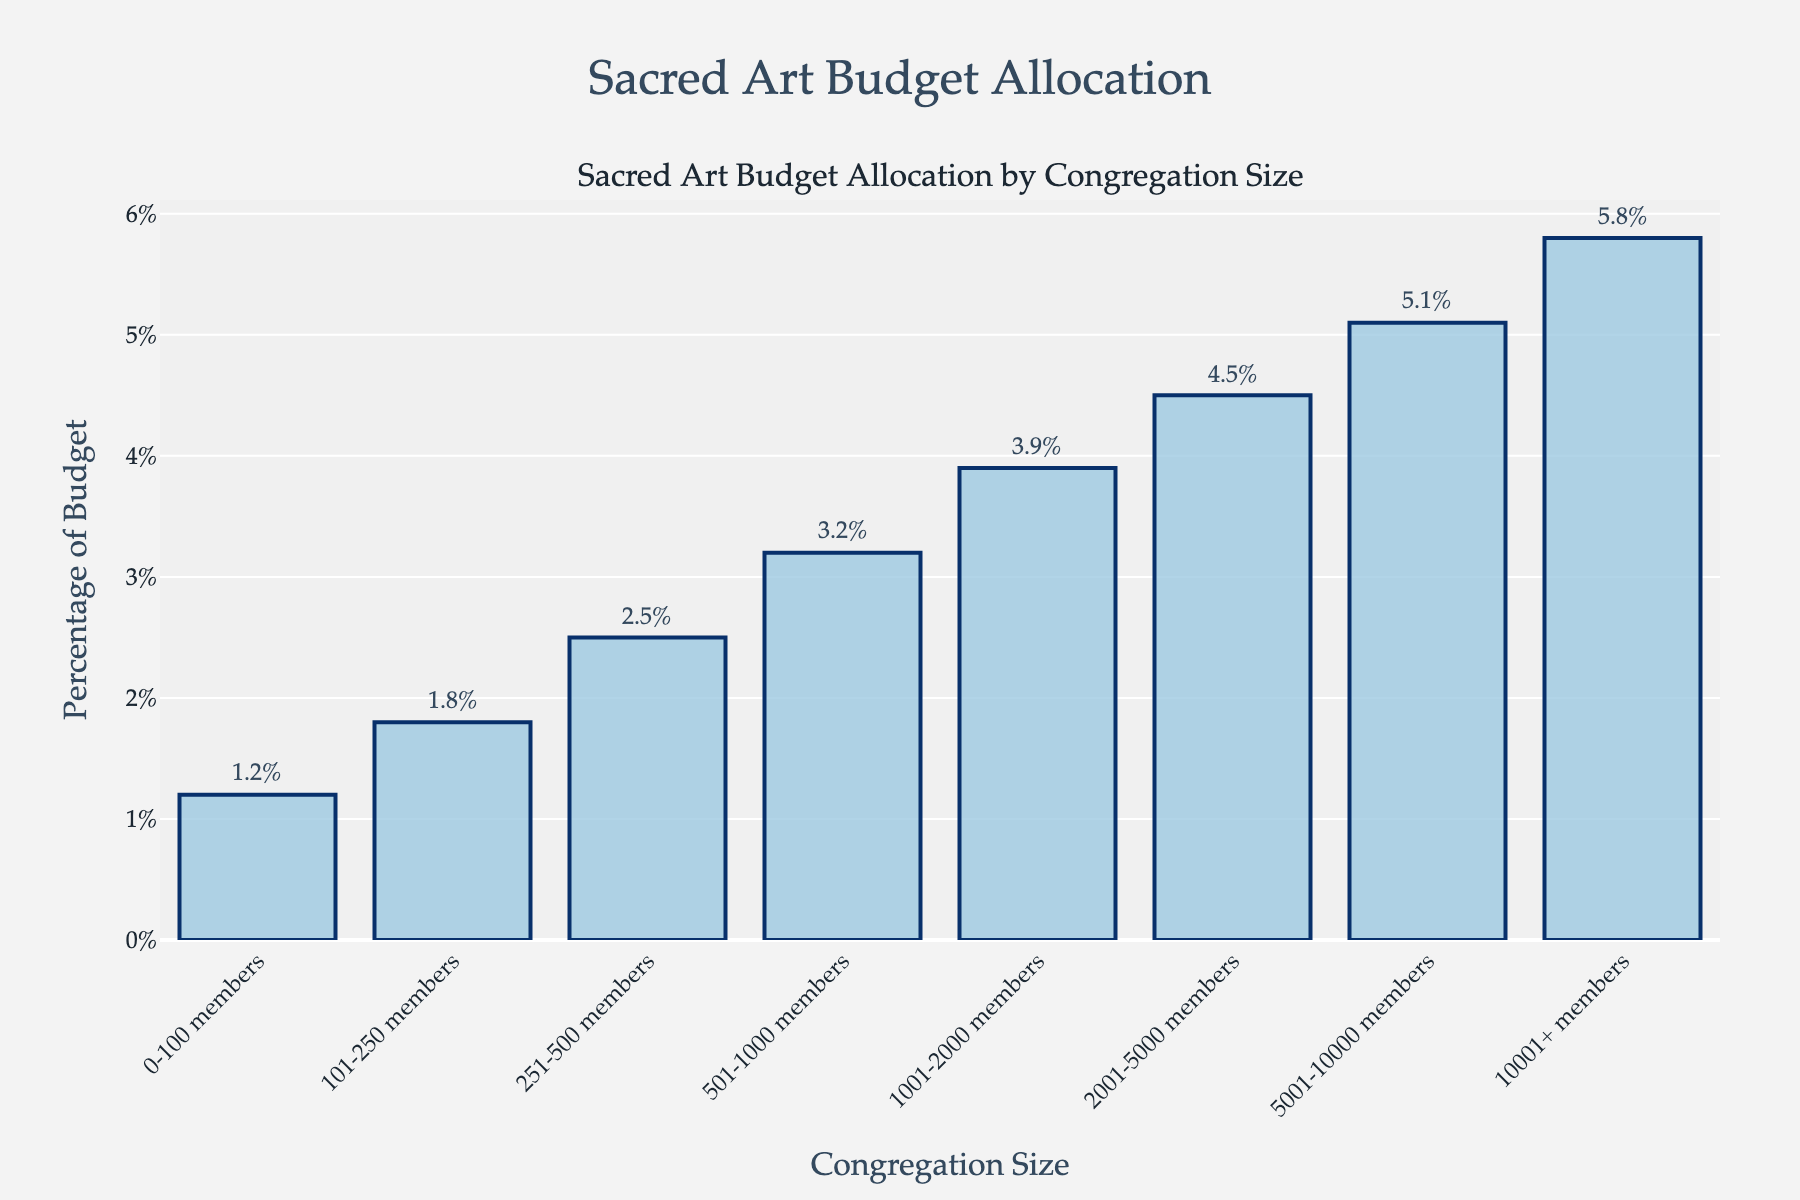How many congregation size categories allocate less than 3% of their budget to sacred art? To answer this, observe the y-axis values for each congregation size category. Count the bars that stay below the 3% mark on the y-axis. There are three such categories.
Answer: 3 By how much does the percentage of the budget for sacred art in congregations with 10001+ members exceed that of congregations with 0-100 members? Look at the percentage values for the congregation sizes 10001+ members and 0-100 members. Subtract the percentage for 0-100 members (1.2%) from the percentage for 10001+ members (5.8%), which results in a difference of 4.6%.
Answer: 4.6% What is the average percentage of the budget for sacred art across all congregation sizes? Add the percentage values for all congregation sizes and divide by the number of categories. Calculations: (1.2 + 1.8 + 2.5 + 3.2 + 3.9 + 4.5 + 5.1 + 5.8) / 8, which equals 3.75%.
Answer: 3.75% Which congregation size has the lowest budget allocation to sacred art, and what percentage is allocated? Compare the height of the bars or the percentage numbers shown for each congregation size. The category with the lowest bar/percentage is 0-100 members, with 1.2%.
Answer: 0-100 members, 1.2% What is the range of budget allocation percentages for sacred art across all congregation sizes? Identify the highest and lowest percentage values from the plot (5.8% for the largest congregation size and 1.2% for the smallest). The range is calculated by subtracting 1.2% from 5.8%, which equals 4.6%.
Answer: 4.6% Which congregation size category has nearly half the budget percentage of the 5001-10000 members category? Find the congregation size with 5001-10000 members, which has a budget percentage of 5.1%. Look for a category whose budget is close to half of 5.1% (approximately 2.55%). The 251-500 members category, with a budget of 2.5%, is closest.
Answer: 251-500 members What trend can be observed in the allocation of budget for sacred art as congregation size increases? Notice the pattern of increasing bar heights and increasing percentage values as the congregation size categories increase. This indicates a positive trend: larger congregation sizes tend to allocate a higher percentage of their budget to sacred art.
Answer: Higher allocation with larger size What is the combined budget percentage for sacred art for congregations with more than 2000 members? Look at the percentages for congregation sizes 2001-5000, 5001-10000, and 10001+ members (4.5%, 5.1%, and 5.8% respectively). Sum these values: 4.5 + 5.1 + 5.8 = 15.4%.
Answer: 15.4% Which congregation size category sees a 0.6% increase in budget allocation for sacred art compared to the next smaller category? Examine percentage differences between consecutive categories. The category 1001-2000 members (3.9%) shows an increase of 0.6% from the 501-1000 members category (3.2%).
Answer: 1001-2000 members How does the budget percentage for sacred art change from the smallest to the largest congregation size? Observe the percentage for the smallest congregation size (1.2% for 0-100 members) and the largest (5.8% for 10001+ members). The increase can be calculated by subtracting 1.2% from 5.8%, giving a 4.6% increase.
Answer: 4.6% 